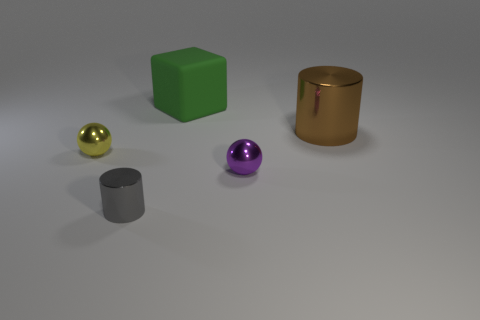Is there anything else that is the same material as the green block?
Give a very brief answer. No. How many objects are tiny gray metallic cylinders or big metal cylinders?
Ensure brevity in your answer.  2. Are the sphere in front of the small yellow thing and the large brown cylinder made of the same material?
Your answer should be compact. Yes. How many objects are either cylinders on the left side of the brown object or blue cubes?
Offer a terse response. 1. The small cylinder that is the same material as the yellow thing is what color?
Make the answer very short. Gray. Is there a gray cylinder of the same size as the brown cylinder?
Your answer should be compact. No. There is a large thing that is on the right side of the small purple metal sphere; is it the same color as the big matte cube?
Your answer should be very brief. No. The shiny thing that is both right of the green rubber cube and in front of the brown metallic thing is what color?
Keep it short and to the point. Purple. What is the shape of the brown thing that is the same size as the block?
Your response must be concise. Cylinder. Is there a small purple metallic object of the same shape as the big rubber object?
Give a very brief answer. No. 